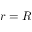<formula> <loc_0><loc_0><loc_500><loc_500>r = R</formula> 